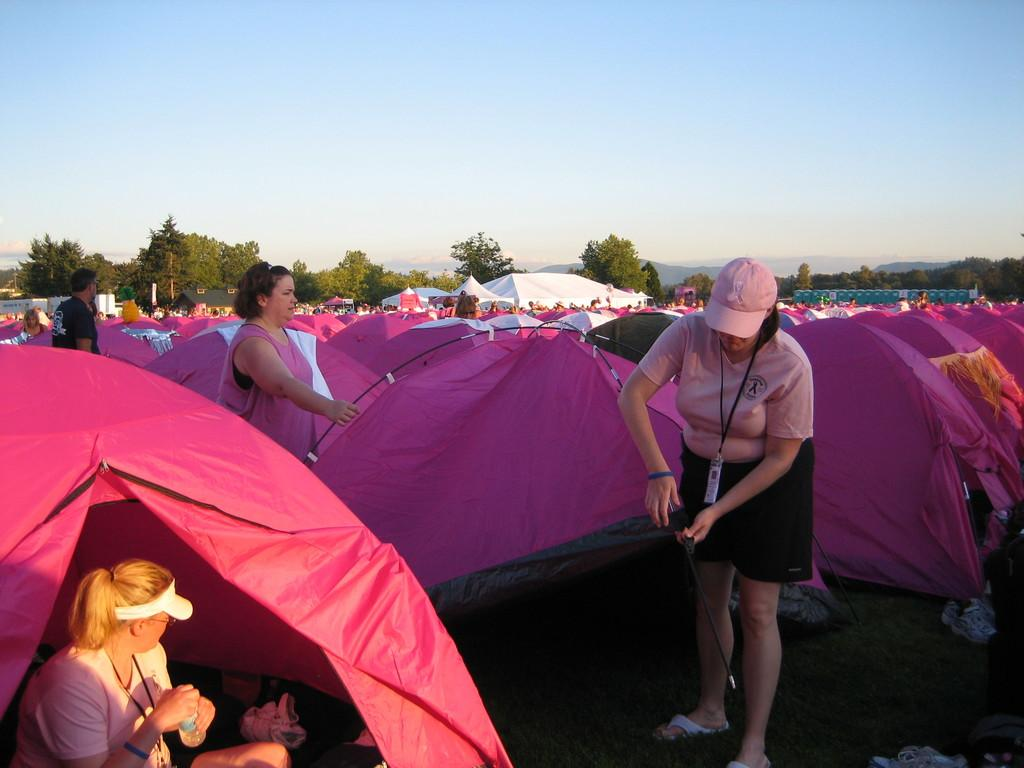What type of temporary shelters can be seen in the image? There are tents in the image. Who is present in the image? There are people in the image. What can be seen in the distance in the image? There is a house and trees in the distance. What is the woman holding in the image? The woman is holding a bottle. What type of clam is being discovered by the people in the image? There is no clam present in the image; the focus is on tents, people, a house, trees, and a woman holding a bottle. 